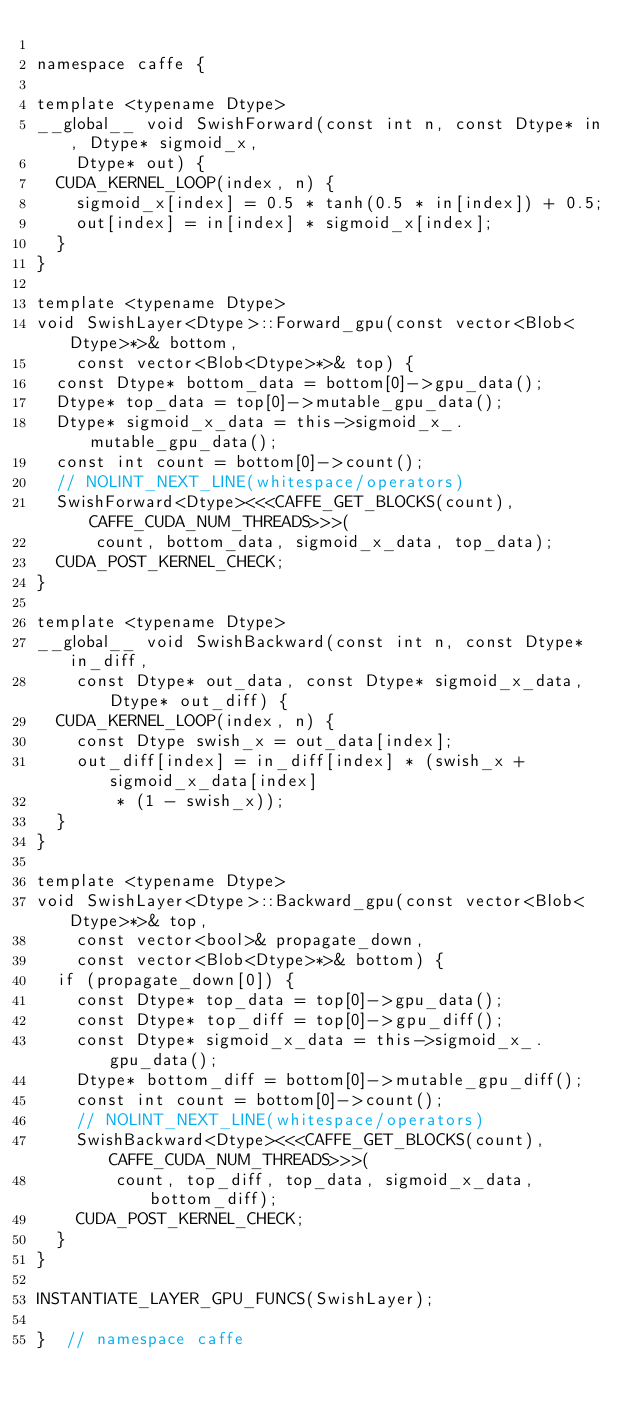Convert code to text. <code><loc_0><loc_0><loc_500><loc_500><_Cuda_>
namespace caffe {

template <typename Dtype>
__global__ void SwishForward(const int n, const Dtype* in, Dtype* sigmoid_x,
    Dtype* out) {
  CUDA_KERNEL_LOOP(index, n) {
    sigmoid_x[index] = 0.5 * tanh(0.5 * in[index]) + 0.5;
    out[index] = in[index] * sigmoid_x[index];
  }
}

template <typename Dtype>
void SwishLayer<Dtype>::Forward_gpu(const vector<Blob<Dtype>*>& bottom,
    const vector<Blob<Dtype>*>& top) {
  const Dtype* bottom_data = bottom[0]->gpu_data();
  Dtype* top_data = top[0]->mutable_gpu_data();
  Dtype* sigmoid_x_data = this->sigmoid_x_.mutable_gpu_data();
  const int count = bottom[0]->count();
  // NOLINT_NEXT_LINE(whitespace/operators)
  SwishForward<Dtype><<<CAFFE_GET_BLOCKS(count), CAFFE_CUDA_NUM_THREADS>>>(
      count, bottom_data, sigmoid_x_data, top_data);
  CUDA_POST_KERNEL_CHECK;
}

template <typename Dtype>
__global__ void SwishBackward(const int n, const Dtype* in_diff,
    const Dtype* out_data, const Dtype* sigmoid_x_data, Dtype* out_diff) {
  CUDA_KERNEL_LOOP(index, n) {
    const Dtype swish_x = out_data[index];
    out_diff[index] = in_diff[index] * (swish_x + sigmoid_x_data[index]
        * (1 - swish_x));
  }
}

template <typename Dtype>
void SwishLayer<Dtype>::Backward_gpu(const vector<Blob<Dtype>*>& top,
    const vector<bool>& propagate_down,
    const vector<Blob<Dtype>*>& bottom) {
  if (propagate_down[0]) {
    const Dtype* top_data = top[0]->gpu_data();
    const Dtype* top_diff = top[0]->gpu_diff();
    const Dtype* sigmoid_x_data = this->sigmoid_x_.gpu_data();
    Dtype* bottom_diff = bottom[0]->mutable_gpu_diff();
    const int count = bottom[0]->count();
    // NOLINT_NEXT_LINE(whitespace/operators)
    SwishBackward<Dtype><<<CAFFE_GET_BLOCKS(count), CAFFE_CUDA_NUM_THREADS>>>(
        count, top_diff, top_data, sigmoid_x_data, bottom_diff);
    CUDA_POST_KERNEL_CHECK;
  }
}

INSTANTIATE_LAYER_GPU_FUNCS(SwishLayer);

}  // namespace caffe
</code> 